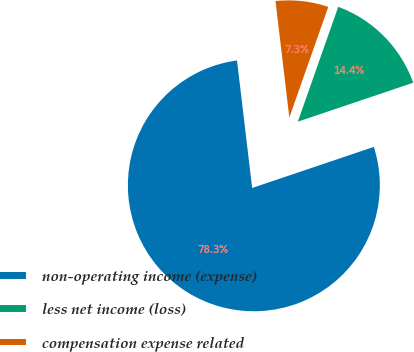<chart> <loc_0><loc_0><loc_500><loc_500><pie_chart><fcel>non-operating income (expense)<fcel>less net income (loss)<fcel>compensation expense related<nl><fcel>78.3%<fcel>14.43%<fcel>7.27%<nl></chart> 